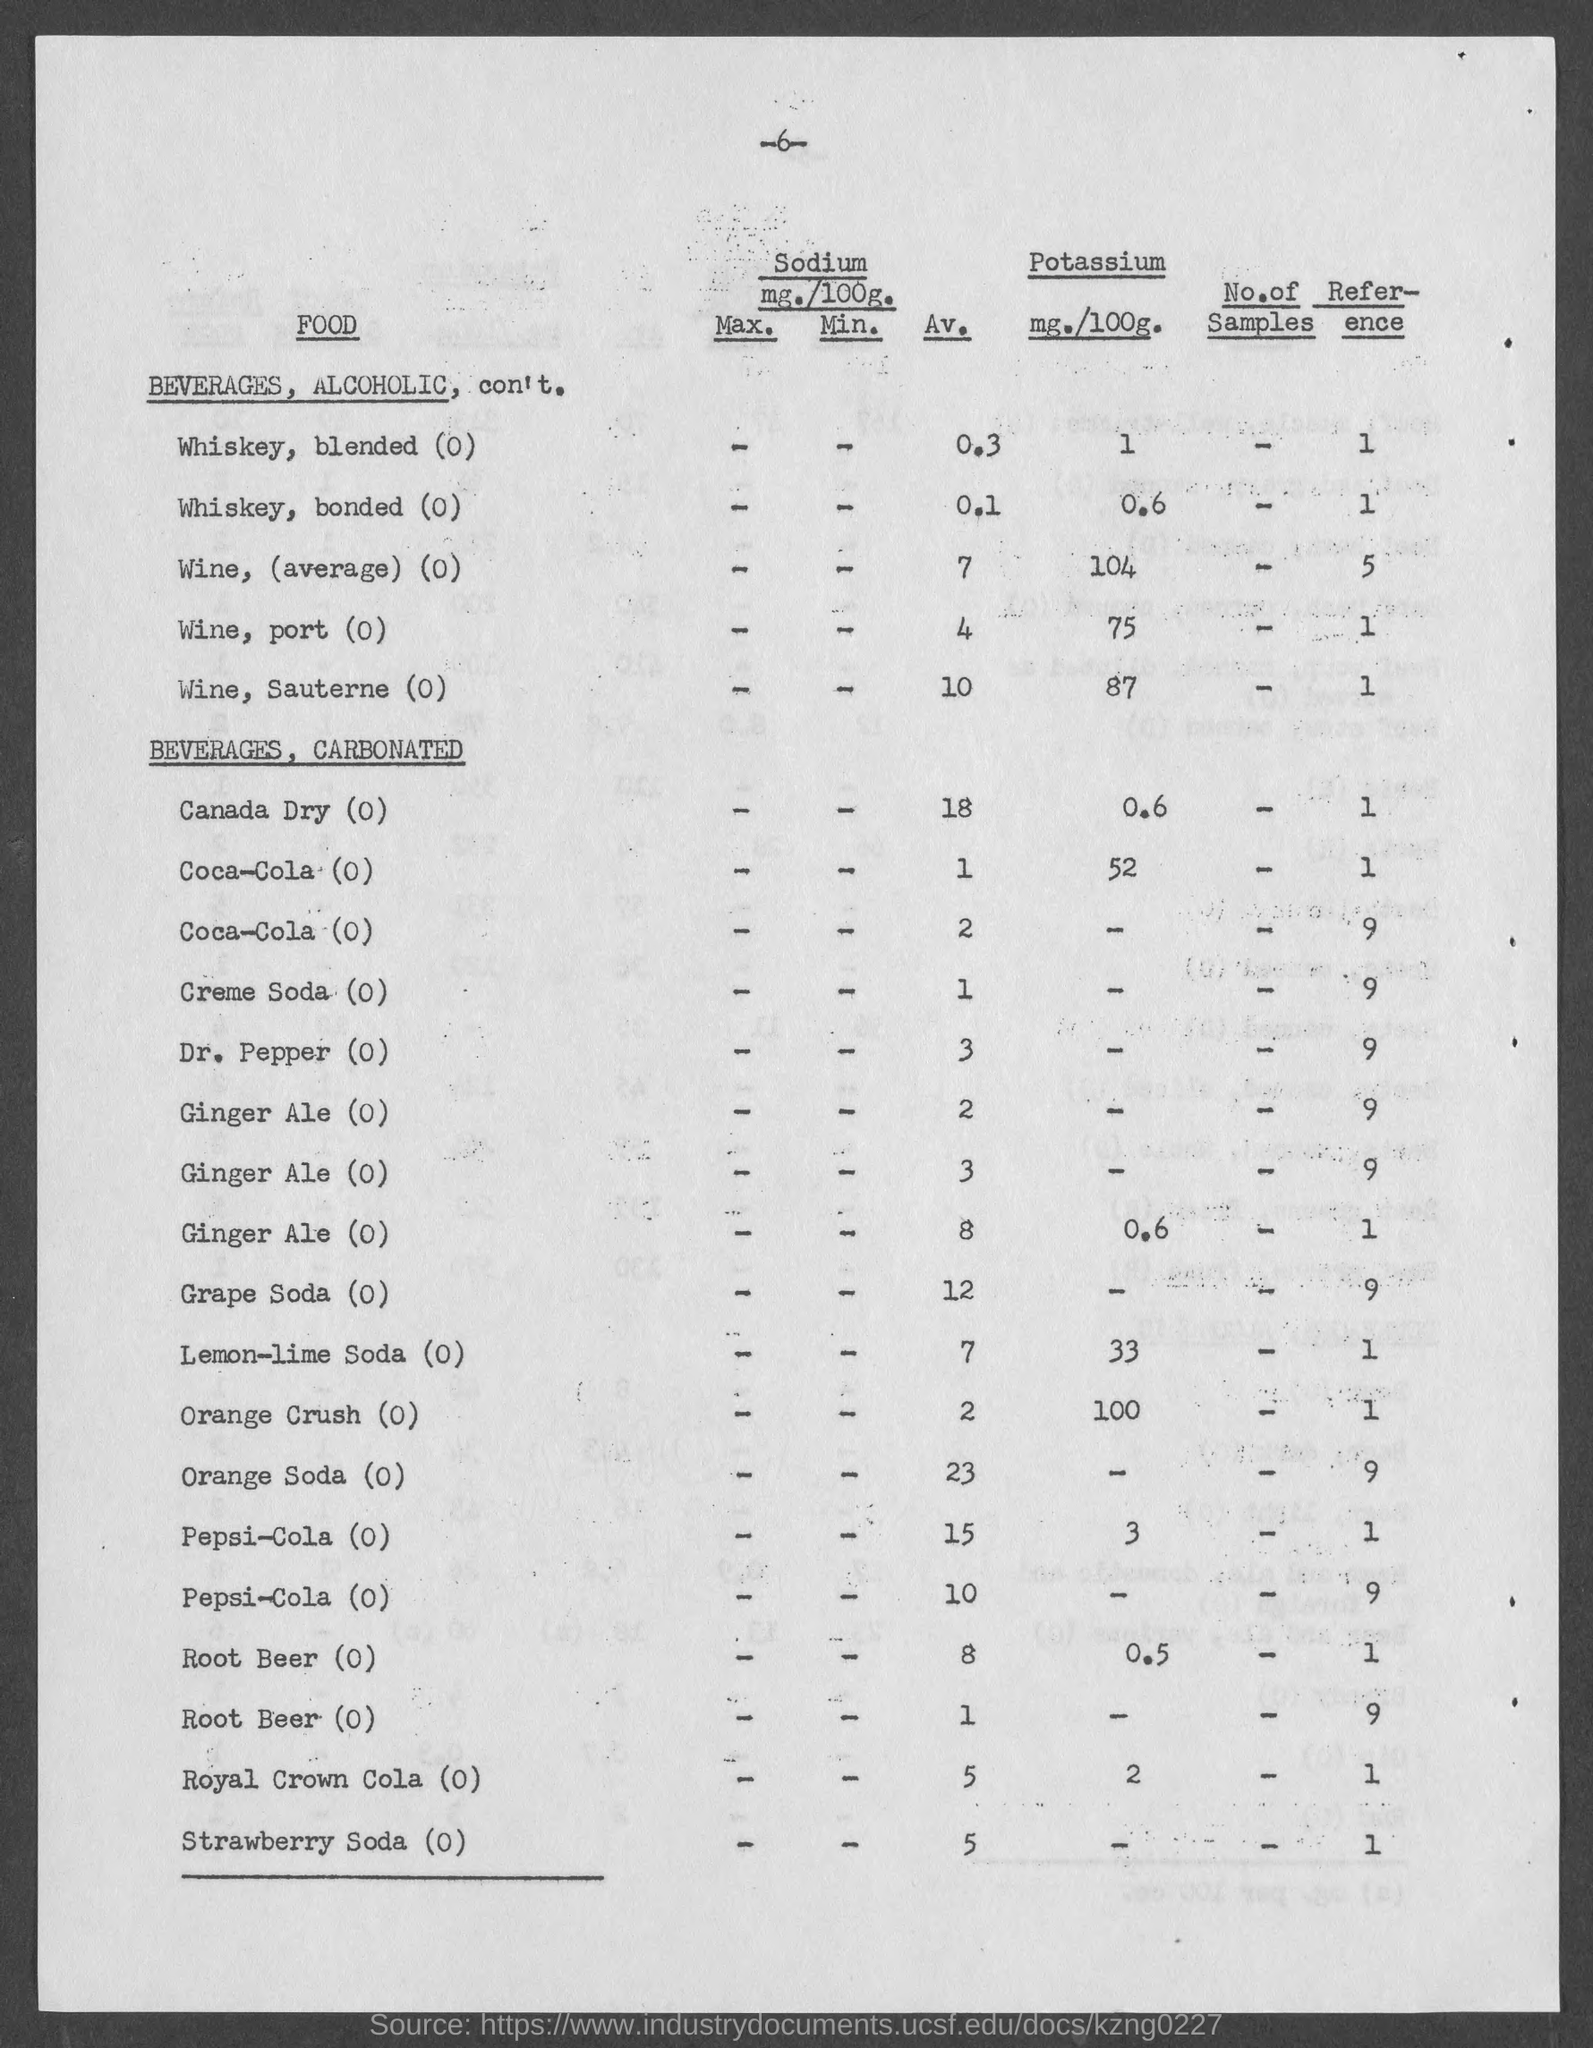Specify some key components in this picture. The sodium content of whiskey, blended (0) is 0.3 milligrams per 100 grams. 